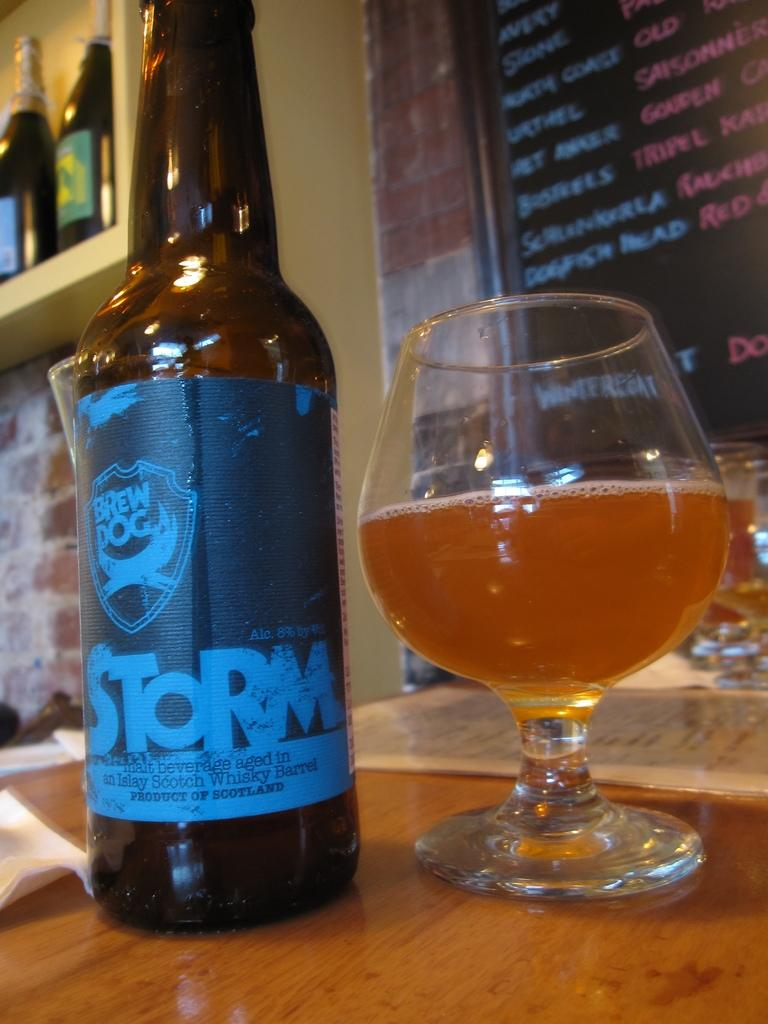<image>
Present a compact description of the photo's key features. the word storm is on a beer bottle 